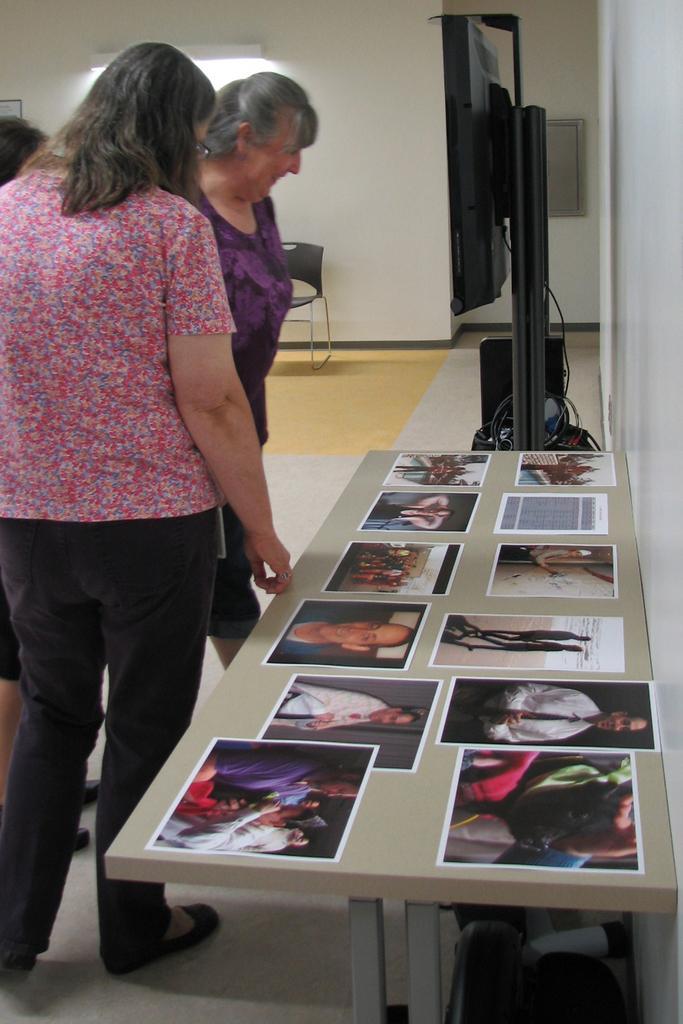Could you give a brief overview of what you see in this image? In this image I see 2 women who are standing and I also see that this woman is smiling. In front I see a table on which there are photos and I see a TV over here. In the background I see the wall, another person, light and a chair. 